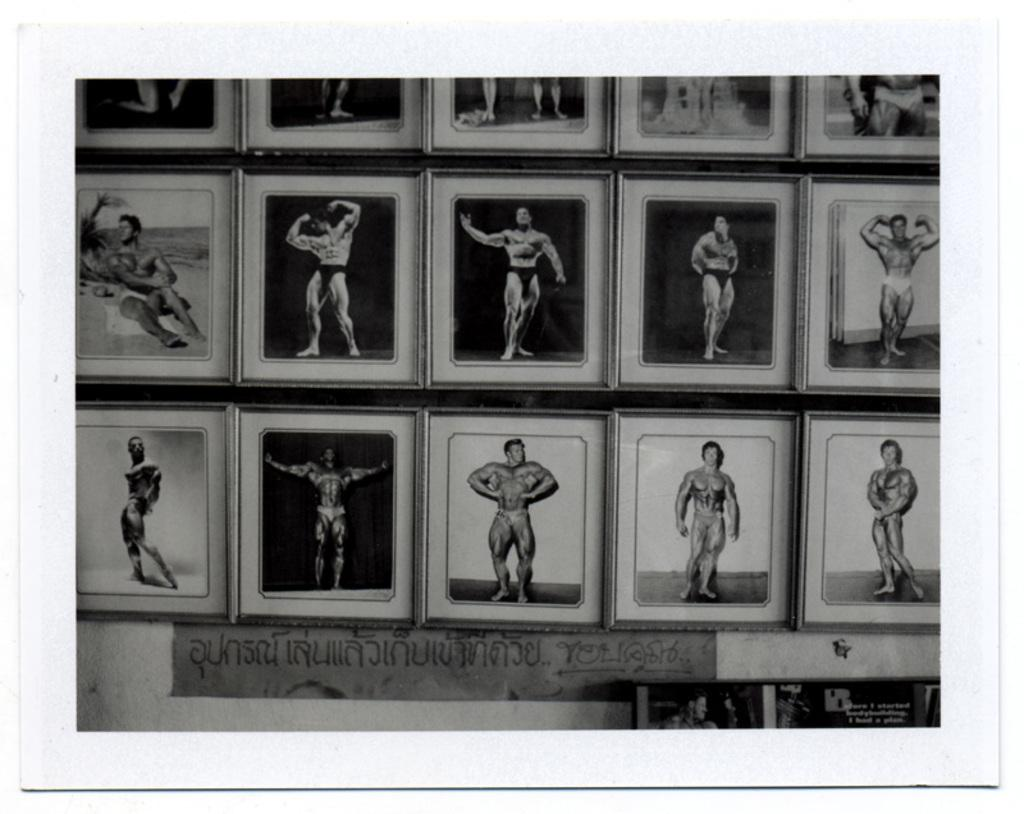What can be seen in the image? There are frames in the image, and within these frames, there are different positions of a person. Can you describe the content of the frames? The frames contain images of a person in various positions or poses. How many children are present in the image? There is no mention of children in the provided facts, so we cannot determine the number of children in the image. 